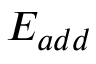<formula> <loc_0><loc_0><loc_500><loc_500>E _ { a d d }</formula> 